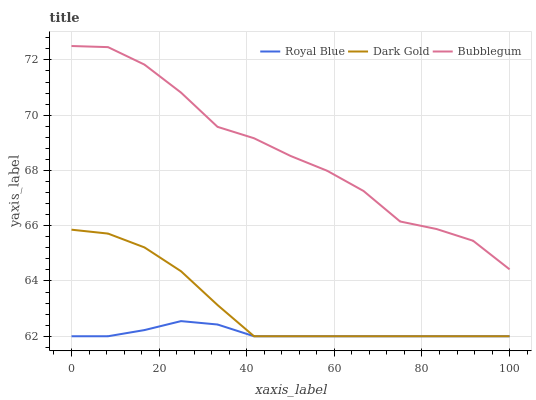Does Dark Gold have the minimum area under the curve?
Answer yes or no. No. Does Dark Gold have the maximum area under the curve?
Answer yes or no. No. Is Dark Gold the smoothest?
Answer yes or no. No. Is Dark Gold the roughest?
Answer yes or no. No. Does Bubblegum have the lowest value?
Answer yes or no. No. Does Dark Gold have the highest value?
Answer yes or no. No. Is Royal Blue less than Bubblegum?
Answer yes or no. Yes. Is Bubblegum greater than Dark Gold?
Answer yes or no. Yes. Does Royal Blue intersect Bubblegum?
Answer yes or no. No. 